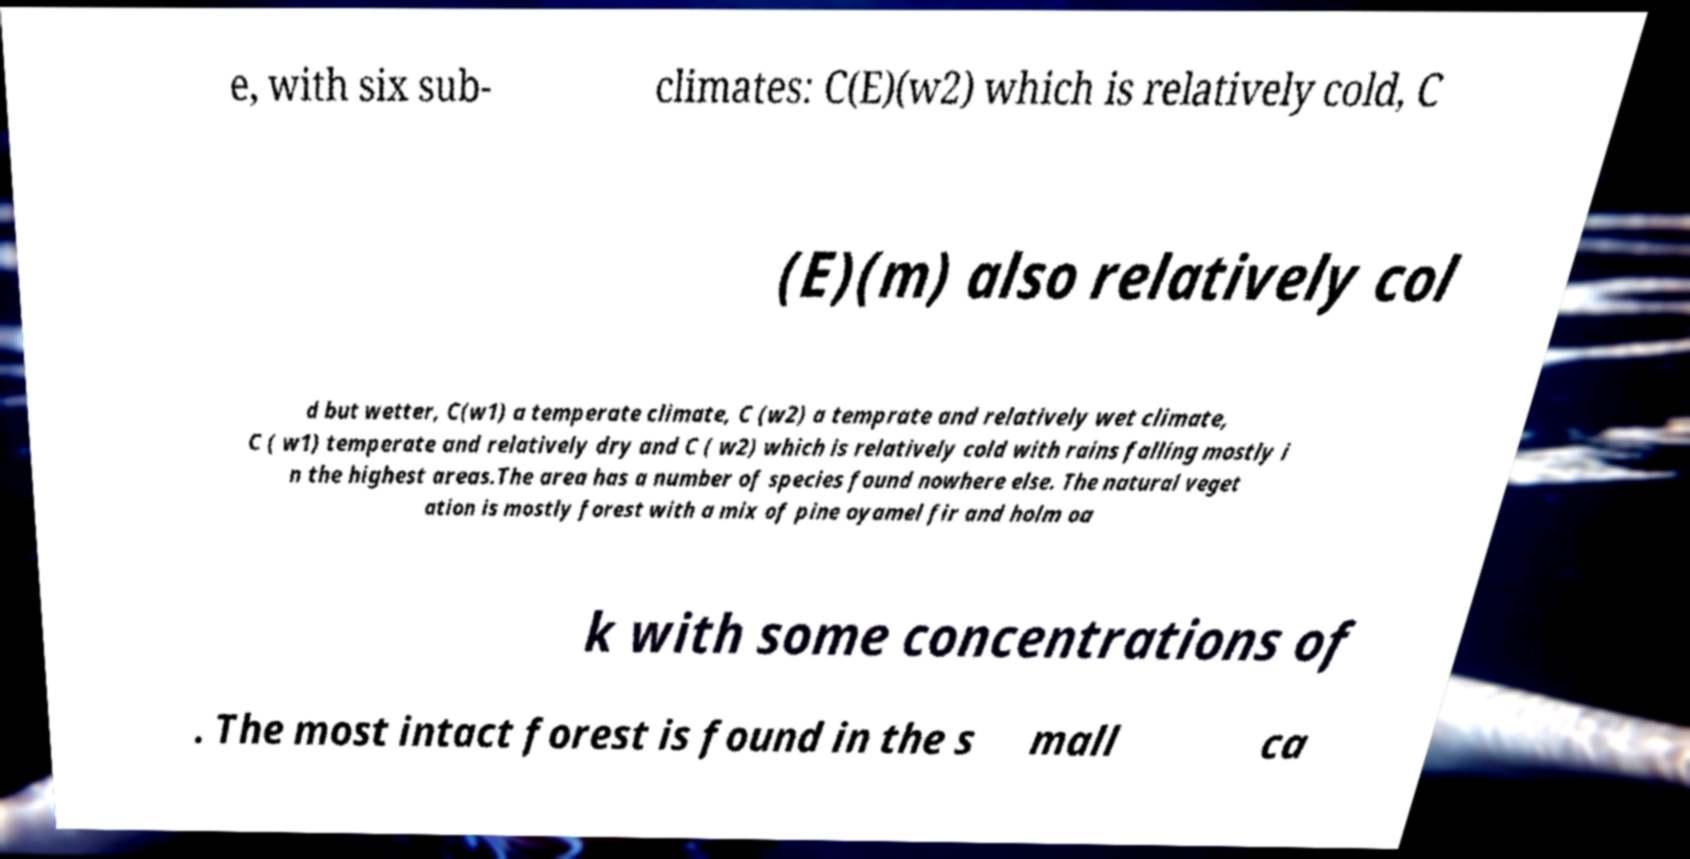For documentation purposes, I need the text within this image transcribed. Could you provide that? e, with six sub- climates: C(E)(w2) which is relatively cold, C (E)(m) also relatively col d but wetter, C(w1) a temperate climate, C (w2) a temprate and relatively wet climate, C ( w1) temperate and relatively dry and C ( w2) which is relatively cold with rains falling mostly i n the highest areas.The area has a number of species found nowhere else. The natural veget ation is mostly forest with a mix of pine oyamel fir and holm oa k with some concentrations of . The most intact forest is found in the s mall ca 